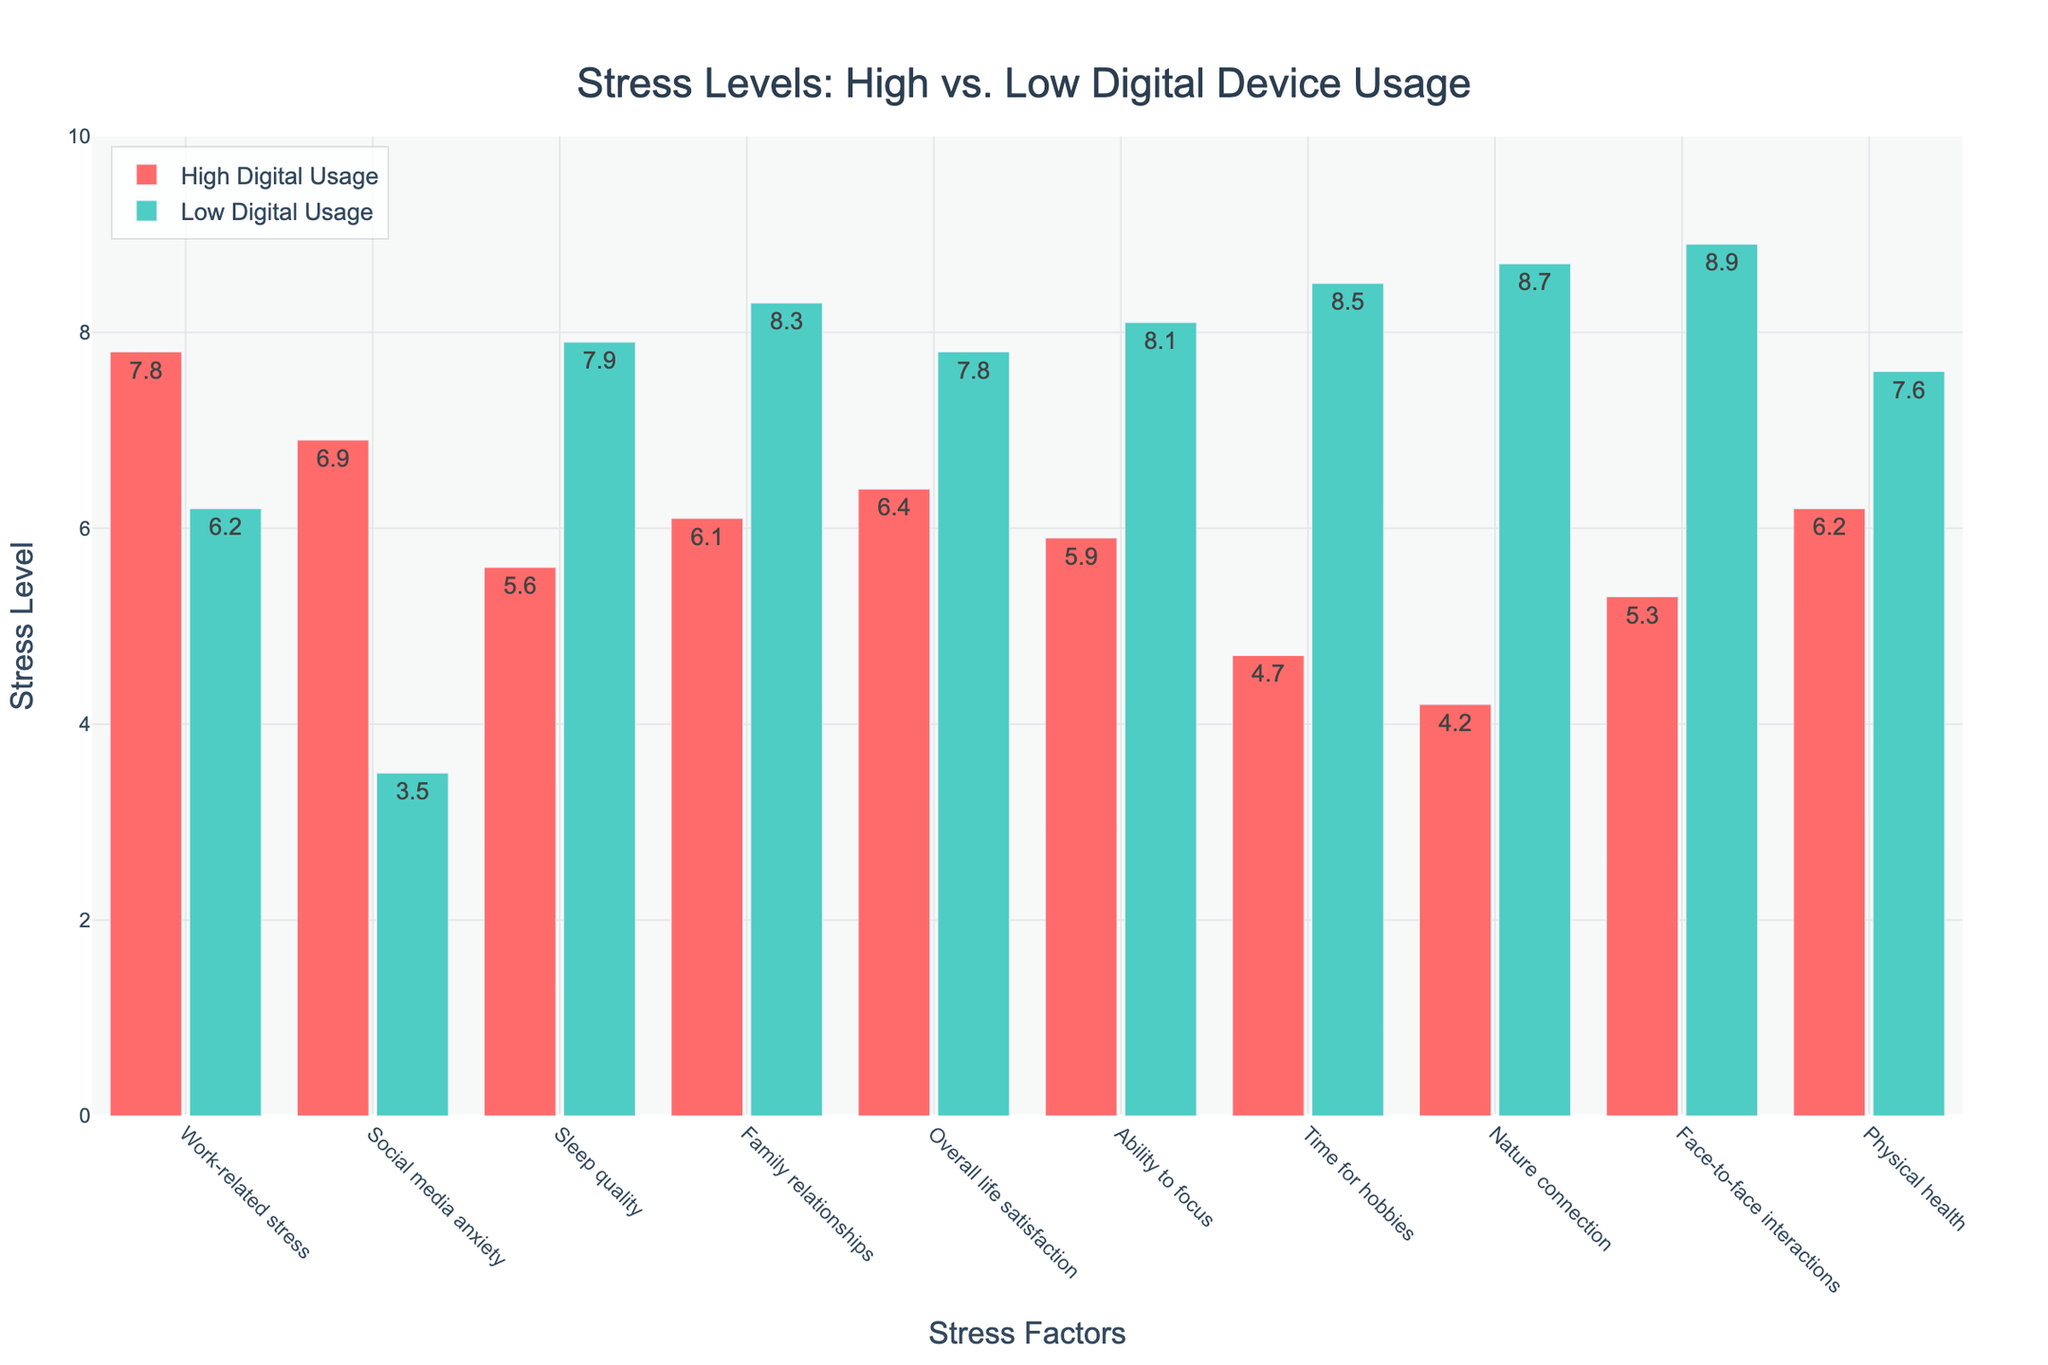What is the difference in stress levels related to social media anxiety between high and low digital device usage? The stress level of social media anxiety for high digital device usage is 6.9, and for low digital device usage, it is 3.5. The difference is calculated by subtracting the lower value from the higher value: 6.9 - 3.5 = 3.4.
Answer: 3.4 Which group has higher overall life satisfaction, high digital usage or low digital usage? The stress level for overall life satisfaction for high digital usage is 6.4, while for low digital usage, it is 7.8. Comparing the two values, 7.8 is greater than 6.4.
Answer: Low digital usage How many stress factors have higher stress levels for high digital device usage than for low digital device usage? By comparing the stress levels for each factor, high digital device usage has higher stress levels in work-related stress, social media anxiety, sleep quality, family relationships, and overall life satisfaction. This counts up to 5 stress factors.
Answer: 5 What is the sum of stress levels for physical health for both high and low digital device usage? The stress levels for physical health are 6.2 for high digital device usage and 7.6 for low digital device usage. Summing them up: 6.2 + 7.6 = 13.8.
Answer: 13.8 Which stress category shows the greatest difference in stress levels between high and low digital device usage? The differences for each category are calculated by subtracting the smaller value from the larger value. The differences are: Work-related stress 7.8 - 6.2 = 1.6, Social media anxiety 6.9 - 3.5 = 3.4, Sleep quality 7.9 - 5.6 = 2.3, Family relationships 8.3 - 6.1 = 2.2, Overall life satisfaction 7.8 - 6.4 = 1.4, Ability to focus 8.1 - 5.9 = 2.2, Time for hobbies 8.5 - 4.7 = 3.8, Nature connection 8.7 - 4.2 = 4.5, Face-to-face interactions 8.9 - 5.3 = 3.6, Physical health 7.6 - 6.2 = 1.4. The greatest difference is in Nature connection: 8.7 - 4.2 = 4.5.
Answer: Nature connection In terms of the ability to focus, how much higher is the stress level for low digital device usage compared to high digital device usage? For ability to focus, the stress level for high digital device usage is 5.9, and for low digital device usage, it is 8.1. The stress is higher by 8.1 - 5.9 = 2.2.
Answer: 2.2 Which group experiences less stress in family relationships? The stress level for family relationships for high digital usage is 6.1, while for low digital usage, it is 8.3. Comparing the two values, 6.1 is less than 8.3.
Answer: High digital usage What is the average stress level across all categories for high digital device usage? The stress levels for high digital device usage are: 7.8, 6.9, 5.6, 6.1, 6.4, 5.9, 4.7, 4.2, 5.3, 6.2. The sum of these values is 58.1. The average is calculated by dividing the sum by the number of categories, which is 10. So, 58.1 / 10 = 5.81.
Answer: 5.81 